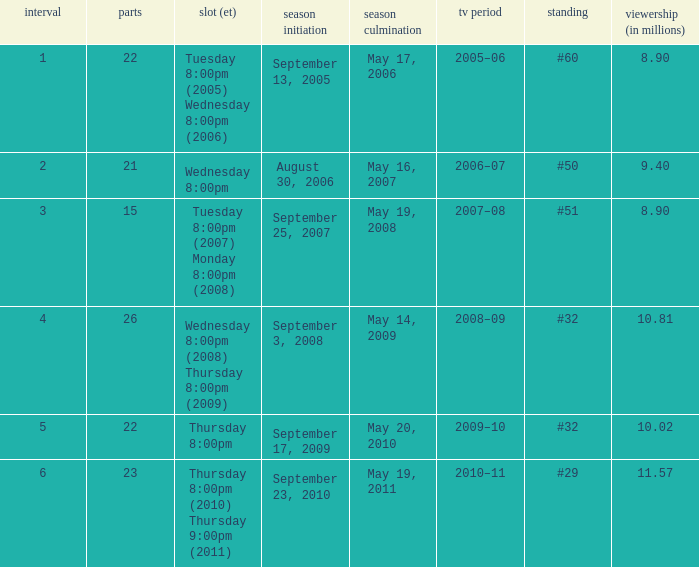When did the season finale reached an audience of 10.02 million viewers? May 20, 2010. 